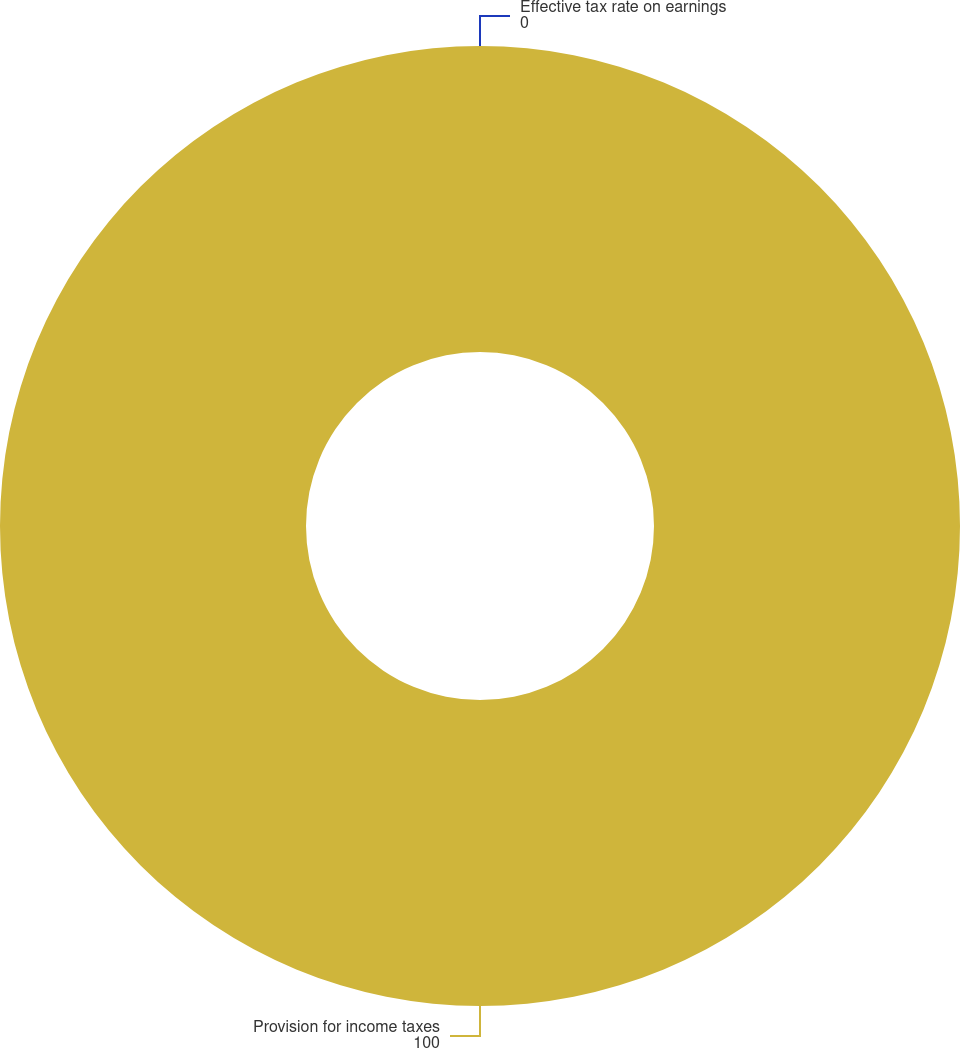<chart> <loc_0><loc_0><loc_500><loc_500><pie_chart><fcel>Provision for income taxes<fcel>Effective tax rate on earnings<nl><fcel>100.0%<fcel>0.0%<nl></chart> 